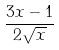Convert formula to latex. <formula><loc_0><loc_0><loc_500><loc_500>\frac { 3 x - 1 } { 2 \sqrt { x } }</formula> 